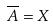Convert formula to latex. <formula><loc_0><loc_0><loc_500><loc_500>\overline { A } = X</formula> 